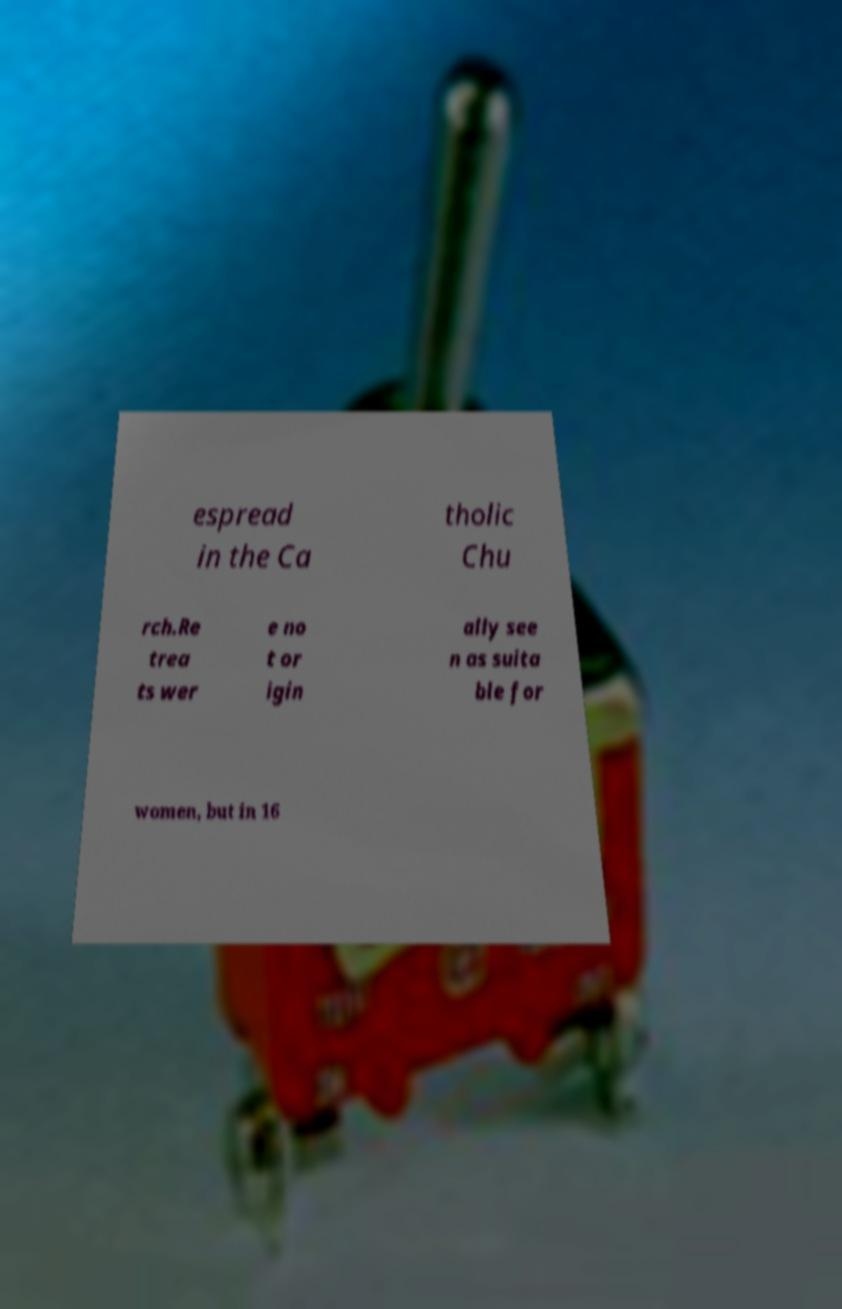I need the written content from this picture converted into text. Can you do that? espread in the Ca tholic Chu rch.Re trea ts wer e no t or igin ally see n as suita ble for women, but in 16 